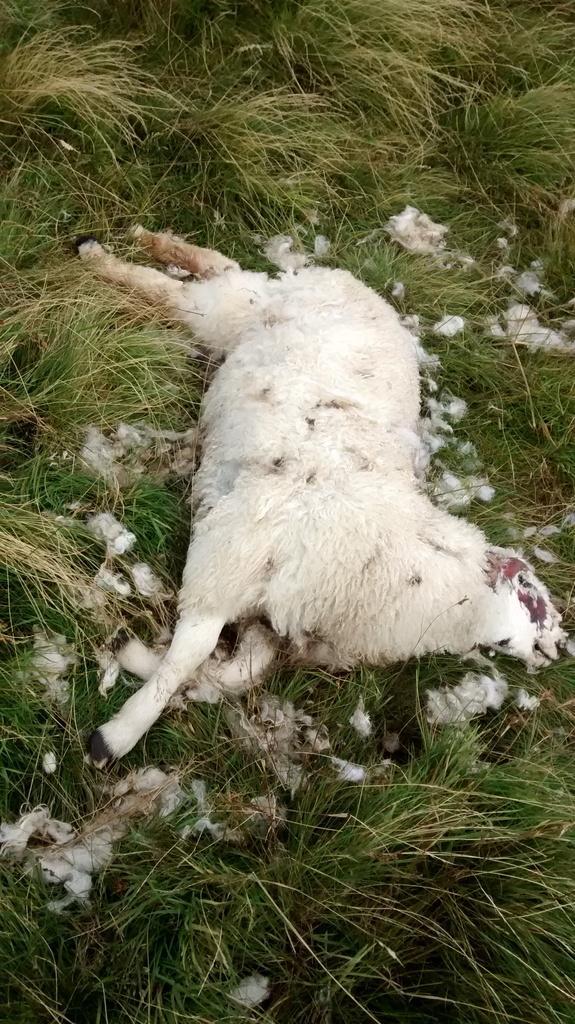Could you give a brief overview of what you see in this image? There is an animal in white color laying on the grass on the ground. And the animal is dead. In the background, there's grass on the ground. 